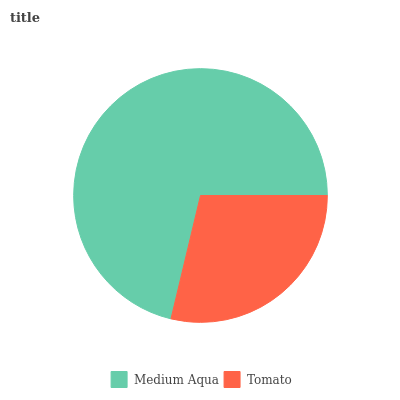Is Tomato the minimum?
Answer yes or no. Yes. Is Medium Aqua the maximum?
Answer yes or no. Yes. Is Tomato the maximum?
Answer yes or no. No. Is Medium Aqua greater than Tomato?
Answer yes or no. Yes. Is Tomato less than Medium Aqua?
Answer yes or no. Yes. Is Tomato greater than Medium Aqua?
Answer yes or no. No. Is Medium Aqua less than Tomato?
Answer yes or no. No. Is Medium Aqua the high median?
Answer yes or no. Yes. Is Tomato the low median?
Answer yes or no. Yes. Is Tomato the high median?
Answer yes or no. No. Is Medium Aqua the low median?
Answer yes or no. No. 